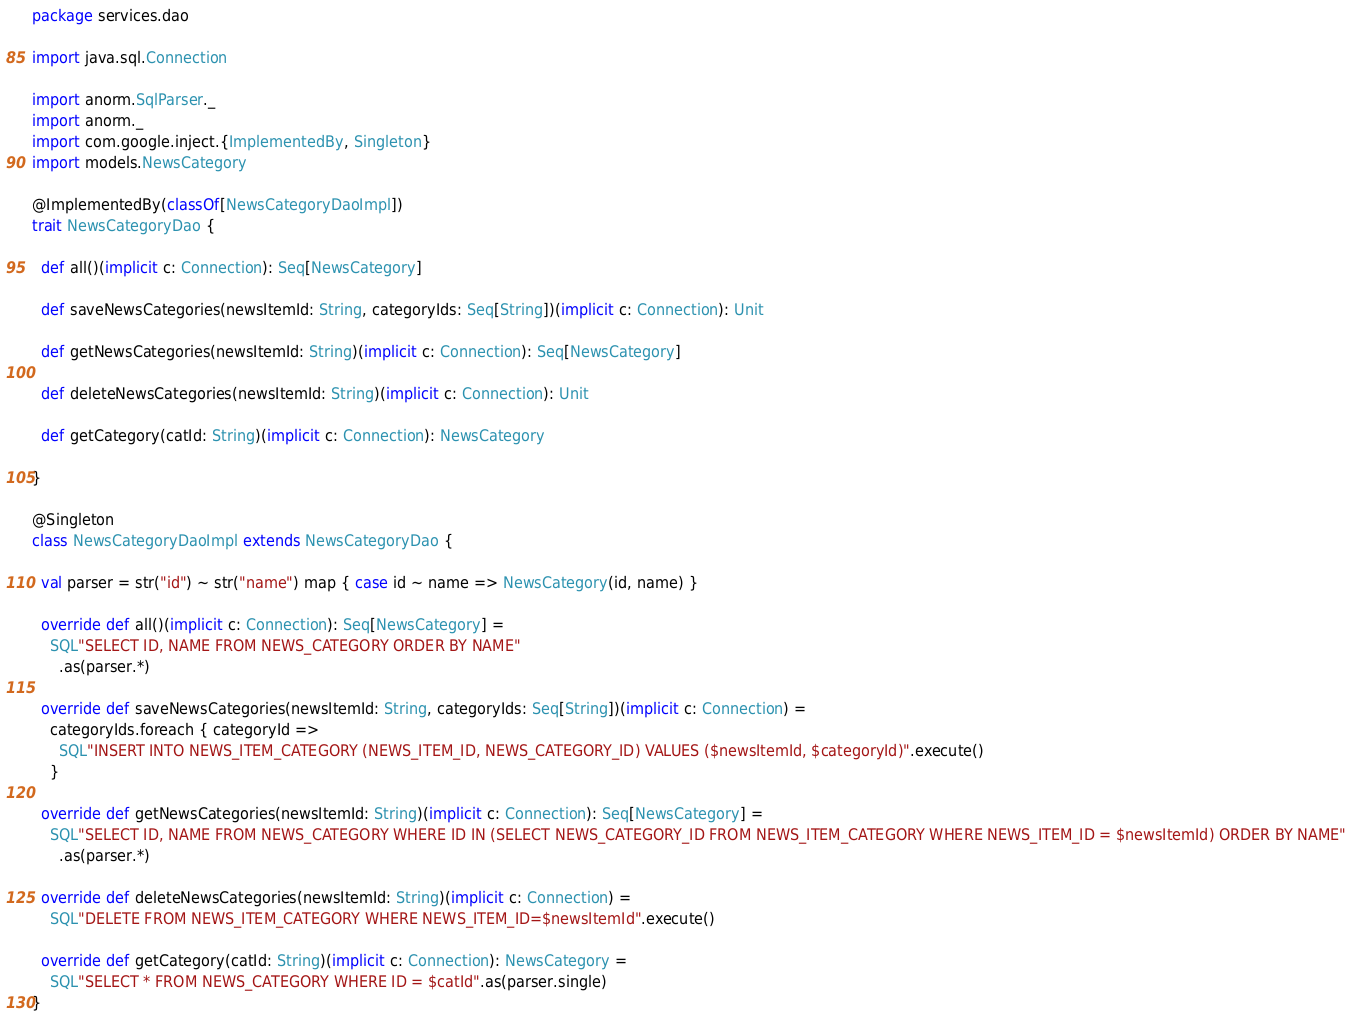<code> <loc_0><loc_0><loc_500><loc_500><_Scala_>package services.dao

import java.sql.Connection

import anorm.SqlParser._
import anorm._
import com.google.inject.{ImplementedBy, Singleton}
import models.NewsCategory

@ImplementedBy(classOf[NewsCategoryDaoImpl])
trait NewsCategoryDao {

  def all()(implicit c: Connection): Seq[NewsCategory]

  def saveNewsCategories(newsItemId: String, categoryIds: Seq[String])(implicit c: Connection): Unit

  def getNewsCategories(newsItemId: String)(implicit c: Connection): Seq[NewsCategory]

  def deleteNewsCategories(newsItemId: String)(implicit c: Connection): Unit

  def getCategory(catId: String)(implicit c: Connection): NewsCategory

}

@Singleton
class NewsCategoryDaoImpl extends NewsCategoryDao {

  val parser = str("id") ~ str("name") map { case id ~ name => NewsCategory(id, name) }

  override def all()(implicit c: Connection): Seq[NewsCategory] =
    SQL"SELECT ID, NAME FROM NEWS_CATEGORY ORDER BY NAME"
      .as(parser.*)

  override def saveNewsCategories(newsItemId: String, categoryIds: Seq[String])(implicit c: Connection) =
    categoryIds.foreach { categoryId =>
      SQL"INSERT INTO NEWS_ITEM_CATEGORY (NEWS_ITEM_ID, NEWS_CATEGORY_ID) VALUES ($newsItemId, $categoryId)".execute()
    }

  override def getNewsCategories(newsItemId: String)(implicit c: Connection): Seq[NewsCategory] =
    SQL"SELECT ID, NAME FROM NEWS_CATEGORY WHERE ID IN (SELECT NEWS_CATEGORY_ID FROM NEWS_ITEM_CATEGORY WHERE NEWS_ITEM_ID = $newsItemId) ORDER BY NAME"
      .as(parser.*)

  override def deleteNewsCategories(newsItemId: String)(implicit c: Connection) =
    SQL"DELETE FROM NEWS_ITEM_CATEGORY WHERE NEWS_ITEM_ID=$newsItemId".execute()

  override def getCategory(catId: String)(implicit c: Connection): NewsCategory =
    SQL"SELECT * FROM NEWS_CATEGORY WHERE ID = $catId".as(parser.single)
}
</code> 